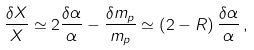Convert formula to latex. <formula><loc_0><loc_0><loc_500><loc_500>\frac { \delta X } { X } \simeq 2 \frac { \delta \alpha } { \alpha } - \frac { \delta m _ { p } } { m _ { p } } \simeq \left ( 2 - R \right ) \frac { \delta \alpha } { \alpha } \, ,</formula> 